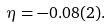Convert formula to latex. <formula><loc_0><loc_0><loc_500><loc_500>\eta = - 0 . 0 8 ( 2 ) .</formula> 